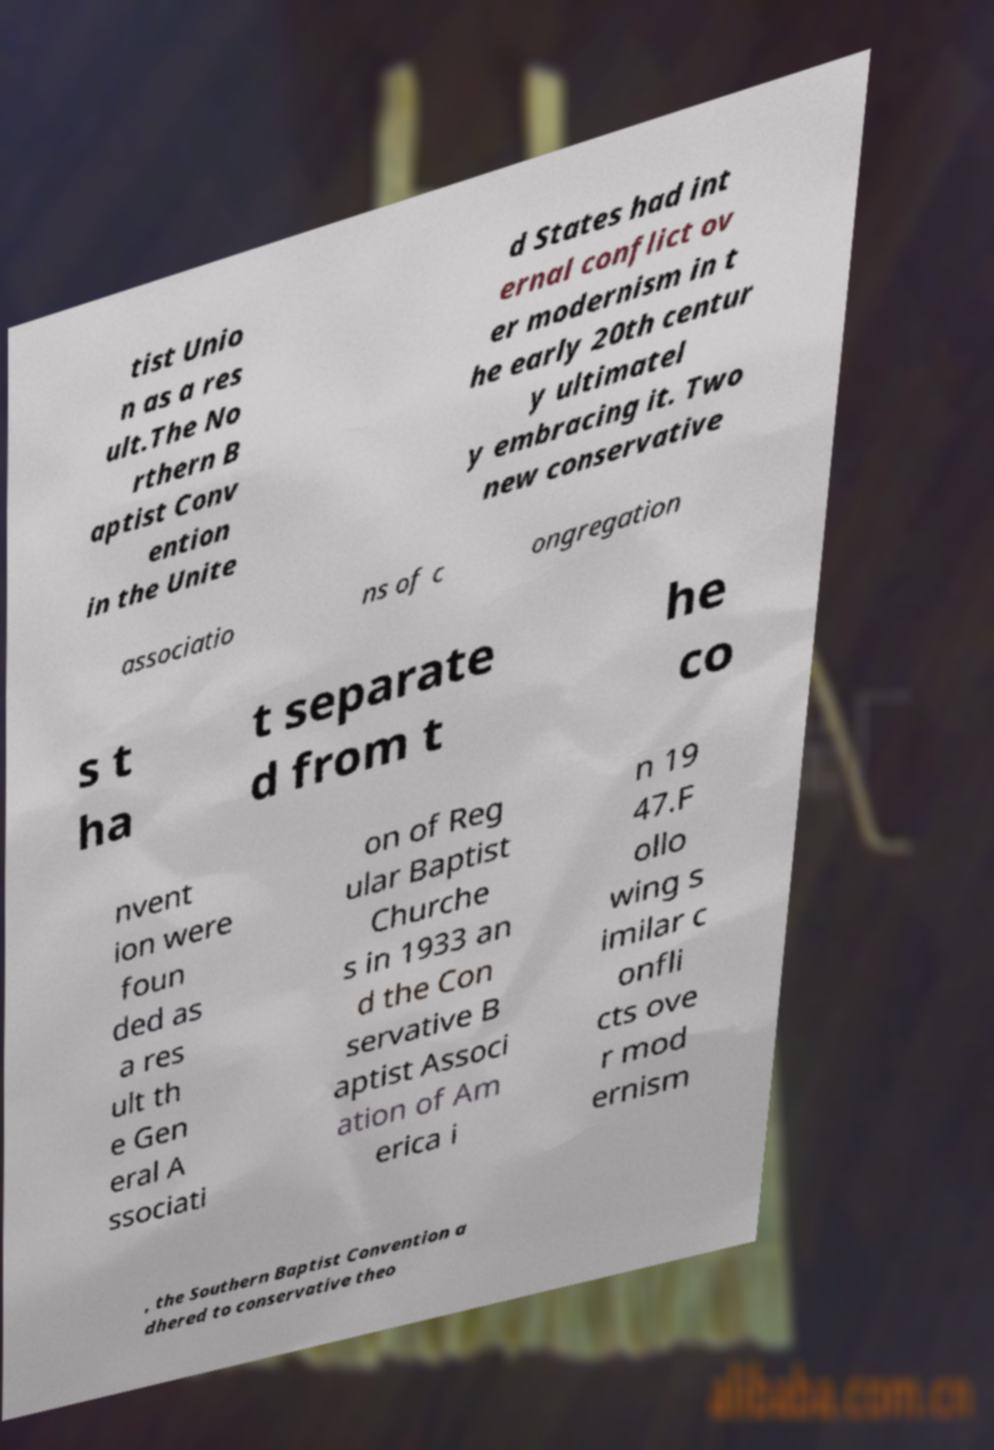Can you accurately transcribe the text from the provided image for me? tist Unio n as a res ult.The No rthern B aptist Conv ention in the Unite d States had int ernal conflict ov er modernism in t he early 20th centur y ultimatel y embracing it. Two new conservative associatio ns of c ongregation s t ha t separate d from t he co nvent ion were foun ded as a res ult th e Gen eral A ssociati on of Reg ular Baptist Churche s in 1933 an d the Con servative B aptist Associ ation of Am erica i n 19 47.F ollo wing s imilar c onfli cts ove r mod ernism , the Southern Baptist Convention a dhered to conservative theo 